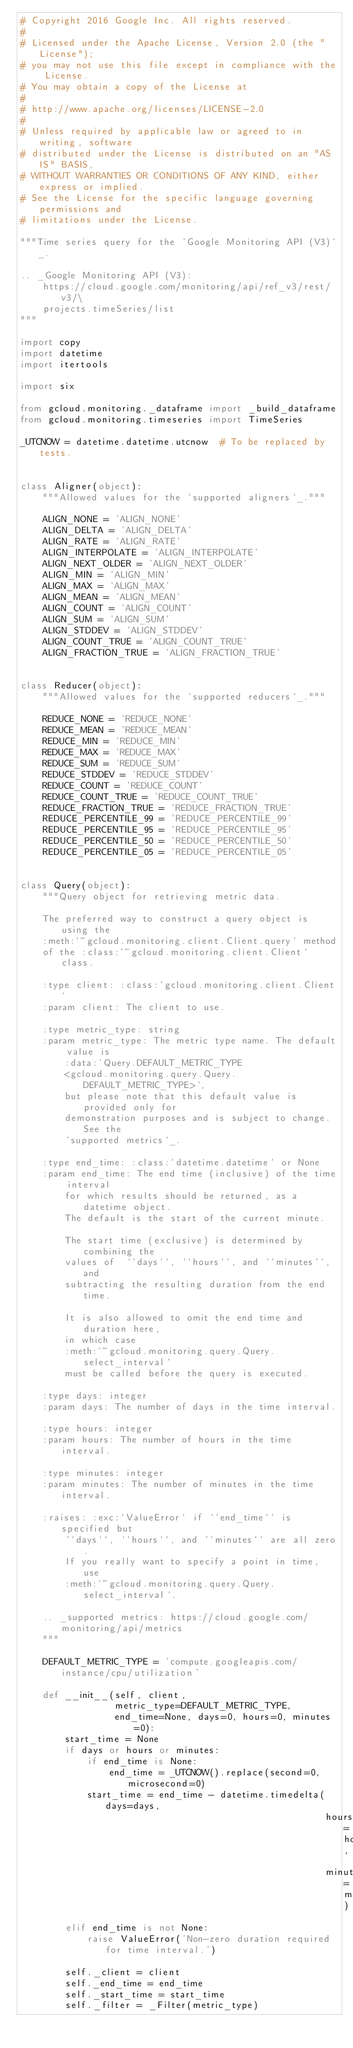<code> <loc_0><loc_0><loc_500><loc_500><_Python_># Copyright 2016 Google Inc. All rights reserved.
#
# Licensed under the Apache License, Version 2.0 (the "License");
# you may not use this file except in compliance with the License.
# You may obtain a copy of the License at
#
# http://www.apache.org/licenses/LICENSE-2.0
#
# Unless required by applicable law or agreed to in writing, software
# distributed under the License is distributed on an "AS IS" BASIS,
# WITHOUT WARRANTIES OR CONDITIONS OF ANY KIND, either express or implied.
# See the License for the specific language governing permissions and
# limitations under the License.

"""Time series query for the `Google Monitoring API (V3)`_.

.. _Google Monitoring API (V3):
    https://cloud.google.com/monitoring/api/ref_v3/rest/v3/\
    projects.timeSeries/list
"""

import copy
import datetime
import itertools

import six

from gcloud.monitoring._dataframe import _build_dataframe
from gcloud.monitoring.timeseries import TimeSeries

_UTCNOW = datetime.datetime.utcnow  # To be replaced by tests.


class Aligner(object):
    """Allowed values for the `supported aligners`_."""

    ALIGN_NONE = 'ALIGN_NONE'
    ALIGN_DELTA = 'ALIGN_DELTA'
    ALIGN_RATE = 'ALIGN_RATE'
    ALIGN_INTERPOLATE = 'ALIGN_INTERPOLATE'
    ALIGN_NEXT_OLDER = 'ALIGN_NEXT_OLDER'
    ALIGN_MIN = 'ALIGN_MIN'
    ALIGN_MAX = 'ALIGN_MAX'
    ALIGN_MEAN = 'ALIGN_MEAN'
    ALIGN_COUNT = 'ALIGN_COUNT'
    ALIGN_SUM = 'ALIGN_SUM'
    ALIGN_STDDEV = 'ALIGN_STDDEV'
    ALIGN_COUNT_TRUE = 'ALIGN_COUNT_TRUE'
    ALIGN_FRACTION_TRUE = 'ALIGN_FRACTION_TRUE'


class Reducer(object):
    """Allowed values for the `supported reducers`_."""

    REDUCE_NONE = 'REDUCE_NONE'
    REDUCE_MEAN = 'REDUCE_MEAN'
    REDUCE_MIN = 'REDUCE_MIN'
    REDUCE_MAX = 'REDUCE_MAX'
    REDUCE_SUM = 'REDUCE_SUM'
    REDUCE_STDDEV = 'REDUCE_STDDEV'
    REDUCE_COUNT = 'REDUCE_COUNT'
    REDUCE_COUNT_TRUE = 'REDUCE_COUNT_TRUE'
    REDUCE_FRACTION_TRUE = 'REDUCE_FRACTION_TRUE'
    REDUCE_PERCENTILE_99 = 'REDUCE_PERCENTILE_99'
    REDUCE_PERCENTILE_95 = 'REDUCE_PERCENTILE_95'
    REDUCE_PERCENTILE_50 = 'REDUCE_PERCENTILE_50'
    REDUCE_PERCENTILE_05 = 'REDUCE_PERCENTILE_05'


class Query(object):
    """Query object for retrieving metric data.

    The preferred way to construct a query object is using the
    :meth:`~gcloud.monitoring.client.Client.query` method
    of the :class:`~gcloud.monitoring.client.Client` class.

    :type client: :class:`gcloud.monitoring.client.Client`
    :param client: The client to use.

    :type metric_type: string
    :param metric_type: The metric type name. The default value is
        :data:`Query.DEFAULT_METRIC_TYPE
        <gcloud.monitoring.query.Query.DEFAULT_METRIC_TYPE>`,
        but please note that this default value is provided only for
        demonstration purposes and is subject to change. See the
        `supported metrics`_.

    :type end_time: :class:`datetime.datetime` or None
    :param end_time: The end time (inclusive) of the time interval
        for which results should be returned, as a datetime object.
        The default is the start of the current minute.

        The start time (exclusive) is determined by combining the
        values of  ``days``, ``hours``, and ``minutes``, and
        subtracting the resulting duration from the end time.

        It is also allowed to omit the end time and duration here,
        in which case
        :meth:`~gcloud.monitoring.query.Query.select_interval`
        must be called before the query is executed.

    :type days: integer
    :param days: The number of days in the time interval.

    :type hours: integer
    :param hours: The number of hours in the time interval.

    :type minutes: integer
    :param minutes: The number of minutes in the time interval.

    :raises: :exc:`ValueError` if ``end_time`` is specified but
        ``days``, ``hours``, and ``minutes`` are all zero.
        If you really want to specify a point in time, use
        :meth:`~gcloud.monitoring.query.Query.select_interval`.

    .. _supported metrics: https://cloud.google.com/monitoring/api/metrics
    """

    DEFAULT_METRIC_TYPE = 'compute.googleapis.com/instance/cpu/utilization'

    def __init__(self, client,
                 metric_type=DEFAULT_METRIC_TYPE,
                 end_time=None, days=0, hours=0, minutes=0):
        start_time = None
        if days or hours or minutes:
            if end_time is None:
                end_time = _UTCNOW().replace(second=0, microsecond=0)
            start_time = end_time - datetime.timedelta(days=days,
                                                       hours=hours,
                                                       minutes=minutes)
        elif end_time is not None:
            raise ValueError('Non-zero duration required for time interval.')

        self._client = client
        self._end_time = end_time
        self._start_time = start_time
        self._filter = _Filter(metric_type)
</code> 